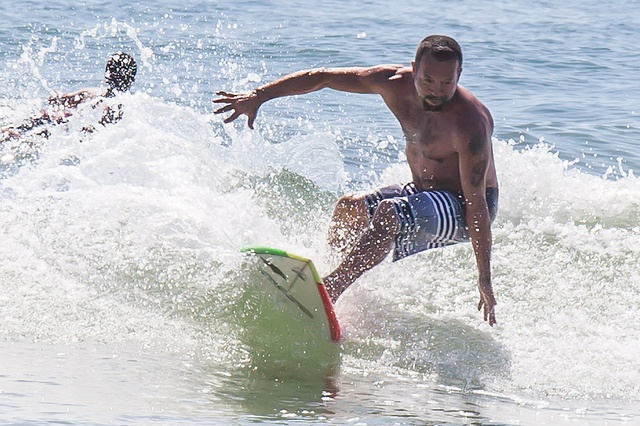Describe the objects in this image and their specific colors. I can see people in lightblue, gray, lightgray, and black tones, surfboard in lightblue, gray, and darkgray tones, and people in lightblue, lightgray, darkgray, gray, and black tones in this image. 